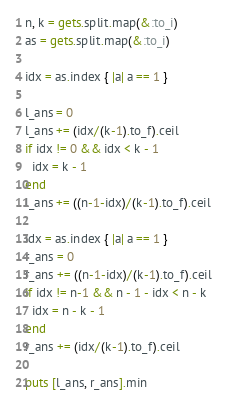<code> <loc_0><loc_0><loc_500><loc_500><_Ruby_>n, k = gets.split.map(&:to_i)
as = gets.split.map(&:to_i)

idx = as.index { |a| a == 1 }

l_ans = 0
l_ans += (idx/(k-1).to_f).ceil
if idx != 0 && idx < k - 1
  idx = k - 1
end
l_ans += ((n-1-idx)/(k-1).to_f).ceil

idx = as.index { |a| a == 1 }
r_ans = 0
r_ans += ((n-1-idx)/(k-1).to_f).ceil
if idx != n-1 && n - 1 - idx < n - k
  idx = n - k - 1
end
r_ans += (idx/(k-1).to_f).ceil

puts [l_ans, r_ans].min</code> 